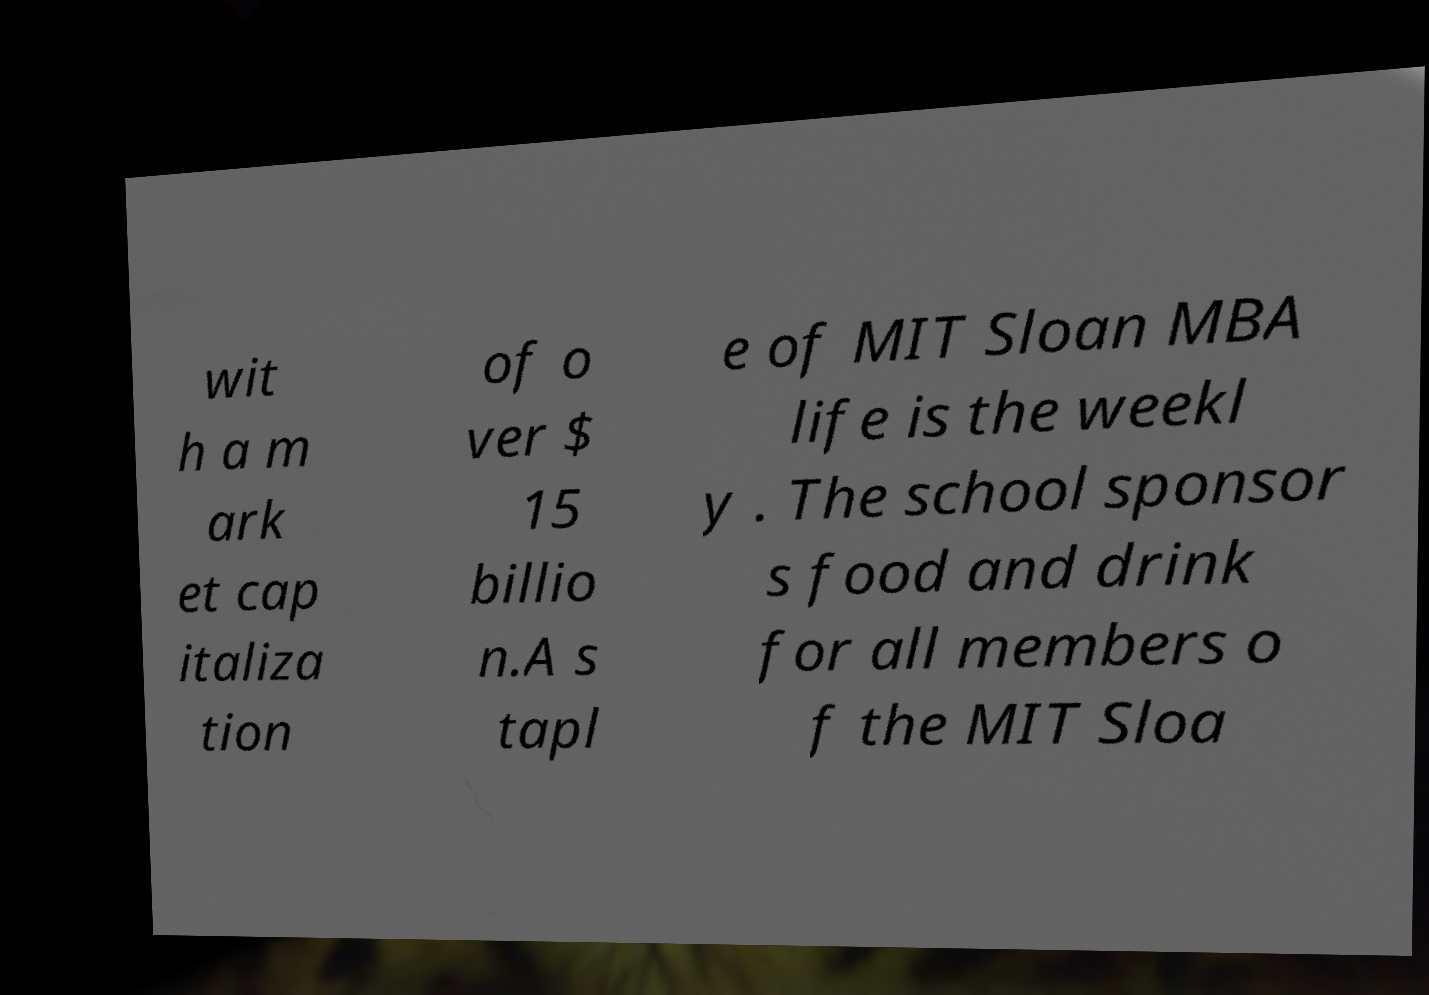I need the written content from this picture converted into text. Can you do that? wit h a m ark et cap italiza tion of o ver $ 15 billio n.A s tapl e of MIT Sloan MBA life is the weekl y . The school sponsor s food and drink for all members o f the MIT Sloa 